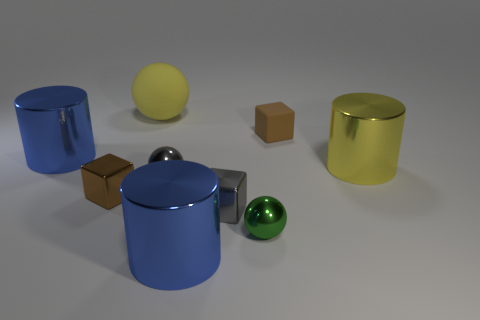Compare the reflective qualities of the cylinders. Do they appear to be made of the same material? While both cylinders exhibit a reflective surface, there are slight differences between them. The cylinder on the left has a more saturated blue color and reflects light in a way that is consistent with a glossier finish. The cylinder on the right reflects light more softly, suggesting a slightly less reflective material, though they could be made of similar materials with different finishes. 